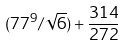<formula> <loc_0><loc_0><loc_500><loc_500>( 7 7 ^ { 9 } / \sqrt { 6 } ) + \frac { 3 1 4 } { 2 7 2 }</formula> 